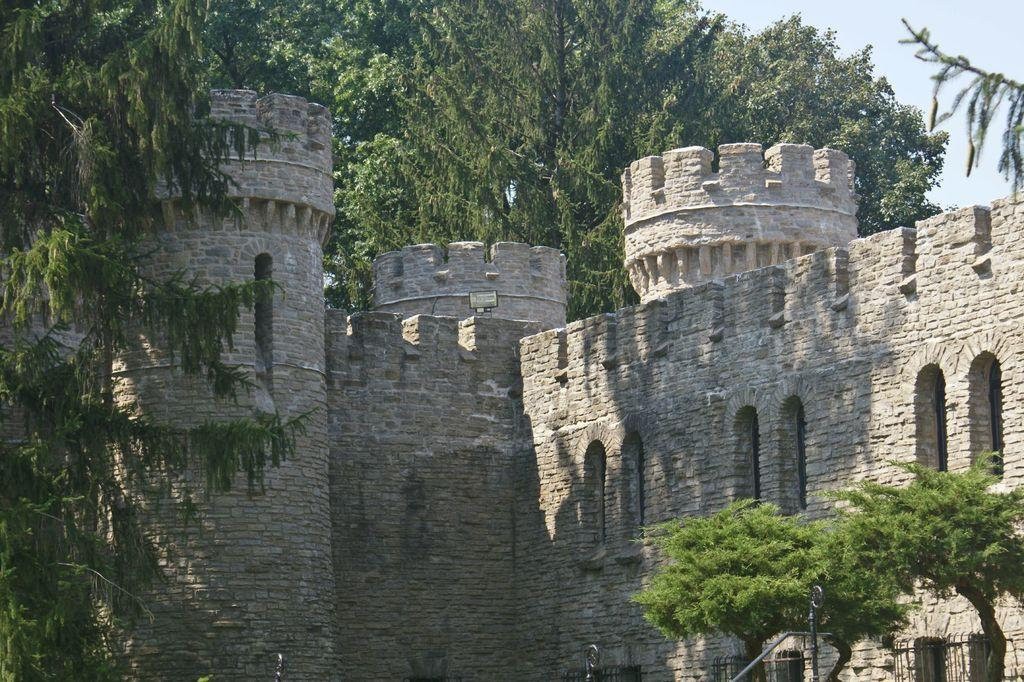What type of structure is in the image? There is an old fort in the image. What can be seen in the background of the image? There are trees visible in the background of the image. How old is the fort in the image? The fact only mentions that it is an old fort, but the exact age is not specified. What type of tax is being discussed in the image? There is no mention of tax in the image, as it features an old fort and trees in the background. 